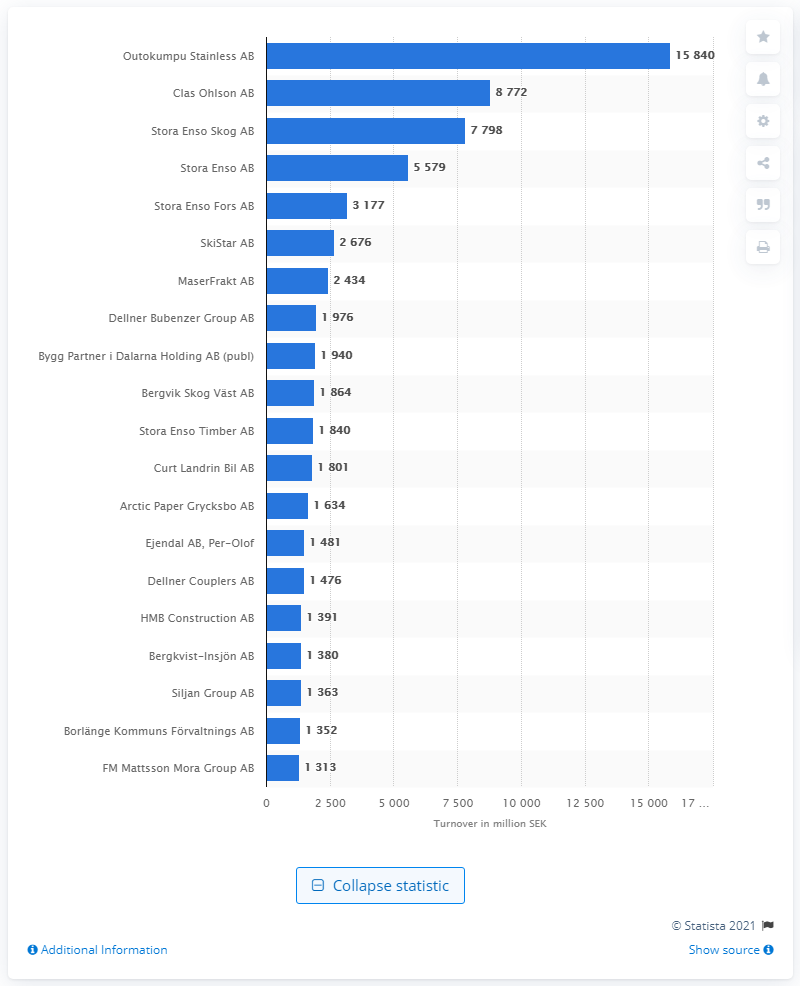Highlight a few significant elements in this photo. Outokumpu Stainless AB generated the largest turnover in Dalarna county in Sweden, according to the company's records. As of February 2021, the turnover of Outokumpu Stainless AB was 15,840. According to the information available, Clas Ohlson AB was the second largest company in terms of turnover in Dalarna county. 